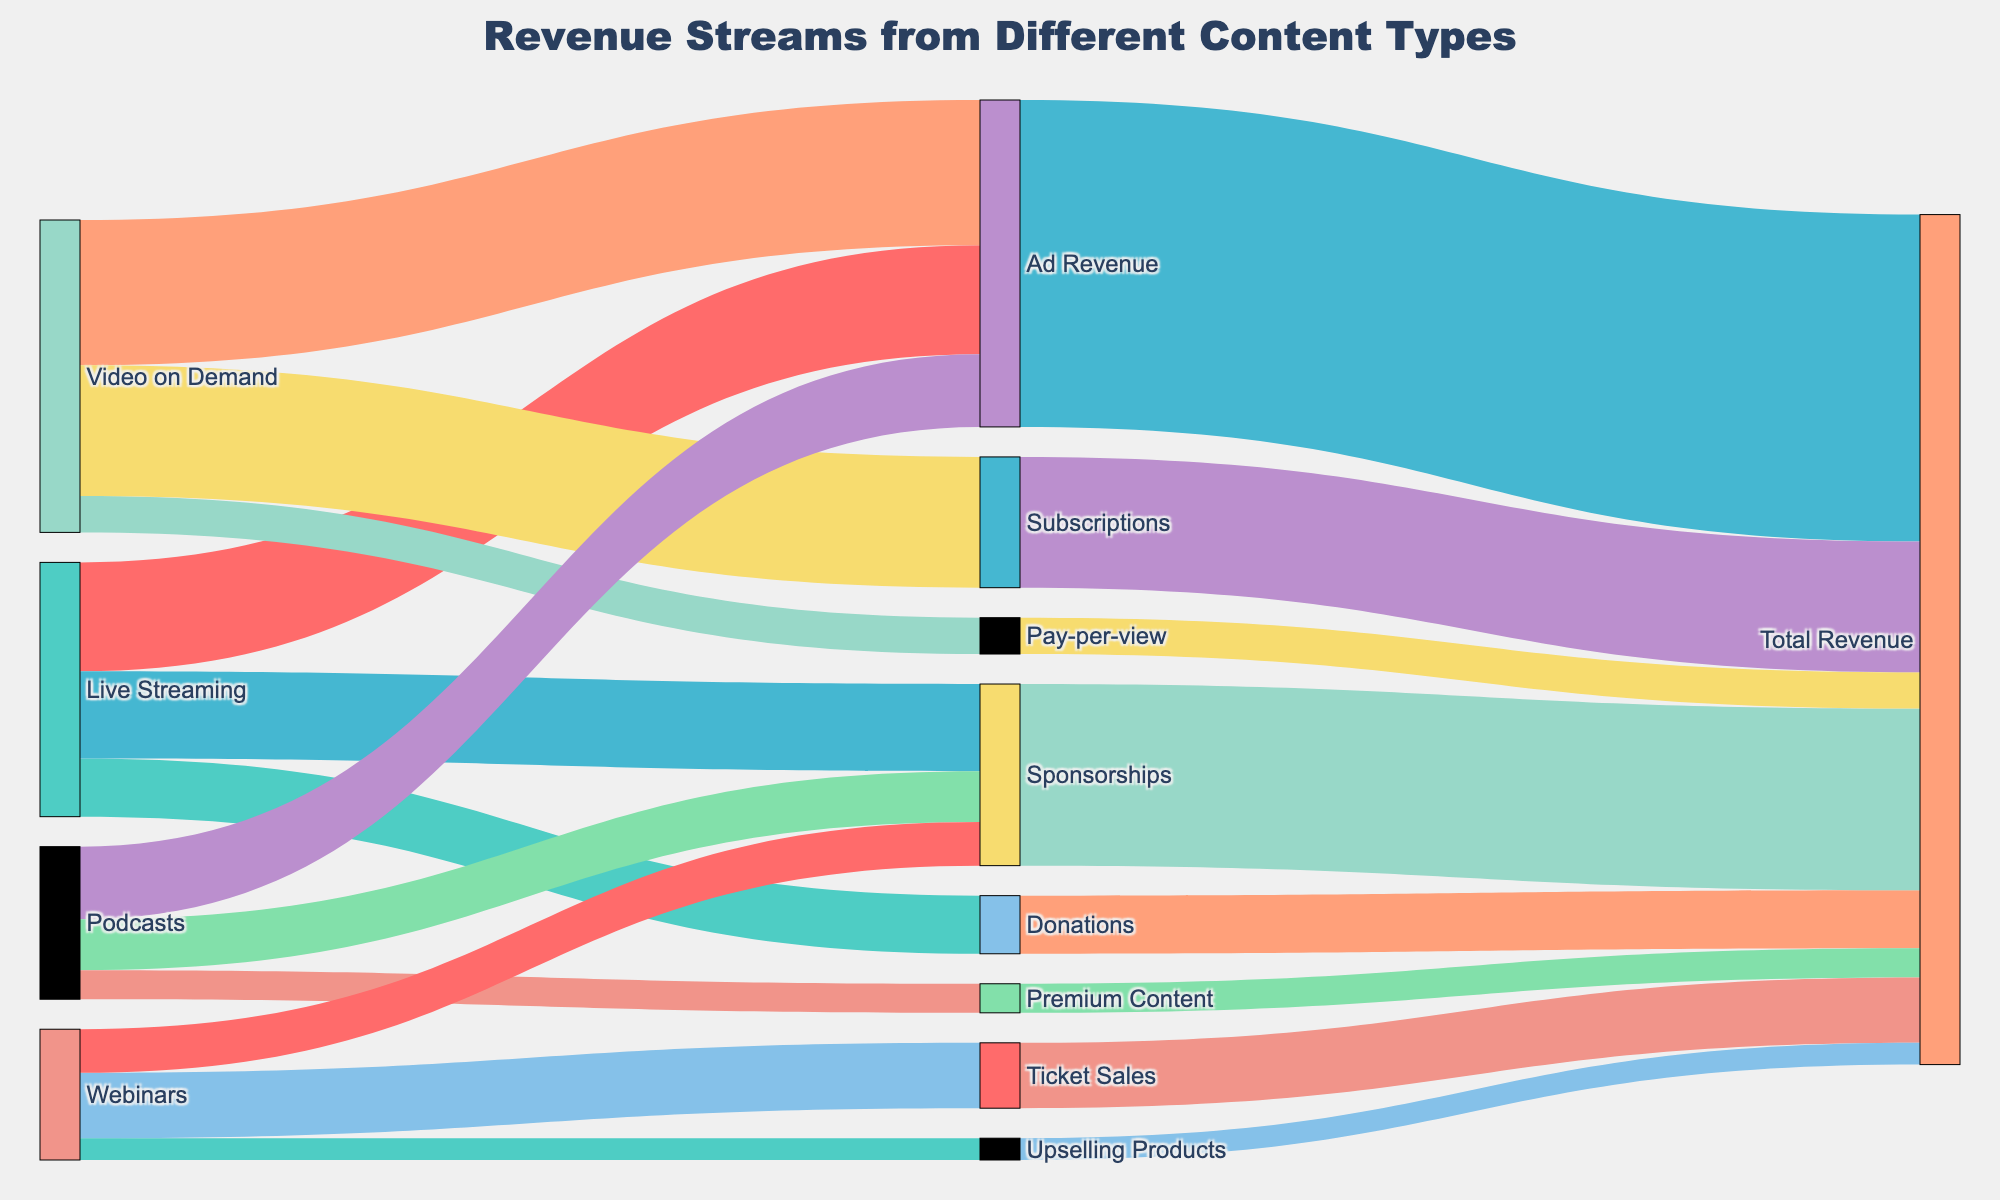How many revenue streams does Live Streaming have? "Live Streaming" connects to three different revenue targets: Ad Revenue, Donations, and Sponsorships, meaning it has three revenue streams.
Answer: Three What type of content generates the most Ad Revenue? By tracing the targets linked to "Ad Revenue," we can see that Video on Demand earns 20,000, Live Streaming 15,000, and Podcasts 10,000, hence Video on Demand generates the most Ad Revenue.
Answer: Video on Demand What is the total revenue generated by Video on Demand content? Summing the values from Video on Demand to different revenue types: 20,000 (Ad Revenue) + 5,000 (Pay-per-view) + 18,000 (Subscriptions) gives the total revenue.
Answer: $43,000 Which content type associated with Subscriptions generates any revenue, and how much? "Video on Demand" is linked with "Subscriptions" yielding a revenue of 18,000.
Answer: $18,000 Which content type has the lowest total revenue? Summing the values flowing into "Total Revenue" for each content type, we identify Webinars with 18,000 in total revenue is higher than podcasts with 21,000, leaving Live Streaming with 35,000 and Video on Demand with 43,000 not lower.
Answer: Webinars Which content type generates income from Upselling Products, and how much? Tracing the links from "Upselling Products," we find that only Webinars provide 3,000 dollars from upselling products.
Answer: Webinars, $3,000 Between Live Streaming and Podcasts, which one contributes more to Sponsorships, and by how much? Live Streaming contributes 12,000, and Podcasts contribute 7,000 to Sponsorships. The difference between these values is 12,000 - 7,000.
Answer: Live Streaming, $5,000 What is the approximate ratio of revenue from Ad Revenue to Donations across all content types? Adding all Ad Revenue streams equals 45,000, Donations contribute 8,000. The approximate ratio is 45,000 to 8,000, simplified to 45:8 or approximately 5.625:1.
Answer: 5.625:1 Which channel brings in revenue through Ticket Sales, and what is the sum of this revenue? Tracing the channel to Ticket Sales, only Webinars contribute, offering a sum revenue of 9,000.
Answer: Webinars, $9,000 Which content type has more diversified revenue streams: Live Streaming or Webinars? Live Streaming has three revenue streams (Ad Revenue, Donations, Sponsorships), and Webinars have three as well (Ticket Sales, Sponsorships, Upselling Products). They are equal in diversification.
Answer: Equal 